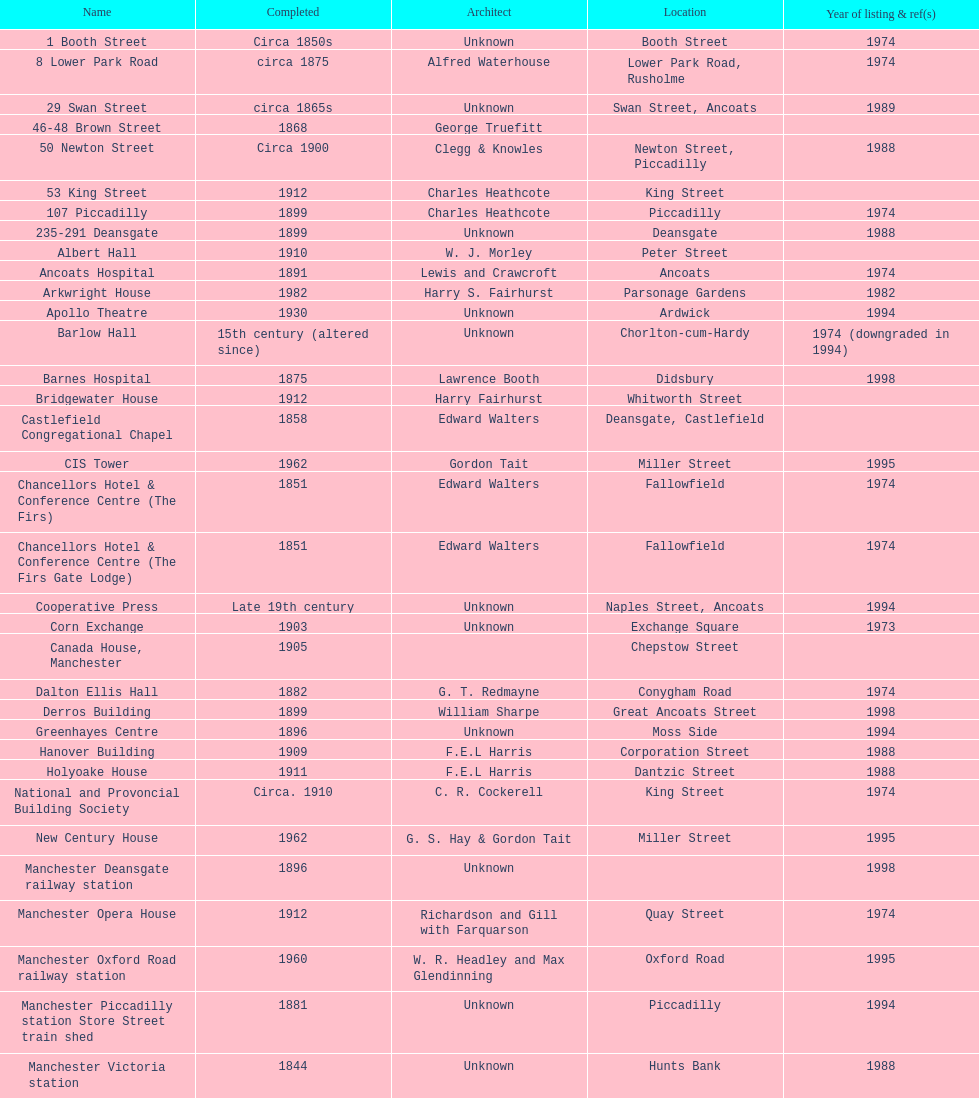I'm looking to parse the entire table for insights. Could you assist me with that? {'header': ['Name', 'Completed', 'Architect', 'Location', 'Year of listing & ref(s)'], 'rows': [['1 Booth Street', 'Circa 1850s', 'Unknown', 'Booth Street', '1974'], ['8 Lower Park Road', 'circa 1875', 'Alfred Waterhouse', 'Lower Park Road, Rusholme', '1974'], ['29 Swan Street', 'circa 1865s', 'Unknown', 'Swan Street, Ancoats', '1989'], ['46-48 Brown Street', '1868', 'George Truefitt', '', ''], ['50 Newton Street', 'Circa 1900', 'Clegg & Knowles', 'Newton Street, Piccadilly', '1988'], ['53 King Street', '1912', 'Charles Heathcote', 'King Street', ''], ['107 Piccadilly', '1899', 'Charles Heathcote', 'Piccadilly', '1974'], ['235-291 Deansgate', '1899', 'Unknown', 'Deansgate', '1988'], ['Albert Hall', '1910', 'W. J. Morley', 'Peter Street', ''], ['Ancoats Hospital', '1891', 'Lewis and Crawcroft', 'Ancoats', '1974'], ['Arkwright House', '1982', 'Harry S. Fairhurst', 'Parsonage Gardens', '1982'], ['Apollo Theatre', '1930', 'Unknown', 'Ardwick', '1994'], ['Barlow Hall', '15th century (altered since)', 'Unknown', 'Chorlton-cum-Hardy', '1974 (downgraded in 1994)'], ['Barnes Hospital', '1875', 'Lawrence Booth', 'Didsbury', '1998'], ['Bridgewater House', '1912', 'Harry Fairhurst', 'Whitworth Street', ''], ['Castlefield Congregational Chapel', '1858', 'Edward Walters', 'Deansgate, Castlefield', ''], ['CIS Tower', '1962', 'Gordon Tait', 'Miller Street', '1995'], ['Chancellors Hotel & Conference Centre (The Firs)', '1851', 'Edward Walters', 'Fallowfield', '1974'], ['Chancellors Hotel & Conference Centre (The Firs Gate Lodge)', '1851', 'Edward Walters', 'Fallowfield', '1974'], ['Cooperative Press', 'Late 19th century', 'Unknown', 'Naples Street, Ancoats', '1994'], ['Corn Exchange', '1903', 'Unknown', 'Exchange Square', '1973'], ['Canada House, Manchester', '1905', '', 'Chepstow Street', ''], ['Dalton Ellis Hall', '1882', 'G. T. Redmayne', 'Conygham Road', '1974'], ['Derros Building', '1899', 'William Sharpe', 'Great Ancoats Street', '1998'], ['Greenhayes Centre', '1896', 'Unknown', 'Moss Side', '1994'], ['Hanover Building', '1909', 'F.E.L Harris', 'Corporation Street', '1988'], ['Holyoake House', '1911', 'F.E.L Harris', 'Dantzic Street', '1988'], ['National and Provoncial Building Society', 'Circa. 1910', 'C. R. Cockerell', 'King Street', '1974'], ['New Century House', '1962', 'G. S. Hay & Gordon Tait', 'Miller Street', '1995'], ['Manchester Deansgate railway station', '1896', 'Unknown', '', '1998'], ['Manchester Opera House', '1912', 'Richardson and Gill with Farquarson', 'Quay Street', '1974'], ['Manchester Oxford Road railway station', '1960', 'W. R. Headley and Max Glendinning', 'Oxford Road', '1995'], ['Manchester Piccadilly station Store Street train shed', '1881', 'Unknown', 'Piccadilly', '1994'], ['Manchester Victoria station', '1844', 'Unknown', 'Hunts Bank', '1988'], ['Palace Theatre', '1891', 'Alfred Derbyshire and F.Bennett Smith', 'Oxford Street', '1977'], ['The Ritz', '1927', 'Unknown', 'Whitworth Street', '1994'], ['Royal Exchange', '1921', 'Bradshaw, Gass & Hope', 'Cross Street', ''], ['Redfern Building', '1936', 'W. A. Johnson and J. W. Cooper', 'Dantzic Street', '1994'], ['Sackville Street Building', '1912', 'Spalding and Cross', 'Sackville Street', '1974'], ['St. James Buildings', '1912', 'Clegg, Fryer & Penman', '65-95 Oxford Street', '1988'], ["St Mary's Hospital", '1909', 'John Ely', 'Wilmslow Road', '1994'], ['Samuel Alexander Building', '1919', 'Percy Scott Worthington', 'Oxford Road', '2010'], ['Ship Canal House', '1927', 'Harry S. Fairhurst', 'King Street', '1982'], ['Smithfield Market Hall', '1857', 'Unknown', 'Swan Street, Ancoats', '1973'], ['Strangeways Gaol Gatehouse', '1868', 'Alfred Waterhouse', 'Sherborne Street', '1974'], ['Strangeways Prison ventilation and watch tower', '1868', 'Alfred Waterhouse', 'Sherborne Street', '1974'], ['Theatre Royal', '1845', 'Irwin and Chester', 'Peter Street', '1974'], ['Toast Rack', '1960', 'L. C. Howitt', 'Fallowfield', '1999'], ['The Old Wellington Inn', 'Mid-16th century', 'Unknown', 'Shambles Square', '1952'], ['Whitworth Park Mansions', 'Circa 1840s', 'Unknown', 'Whitworth Park', '1974']]} What quantity of buildings have no images included in their listing? 11. 